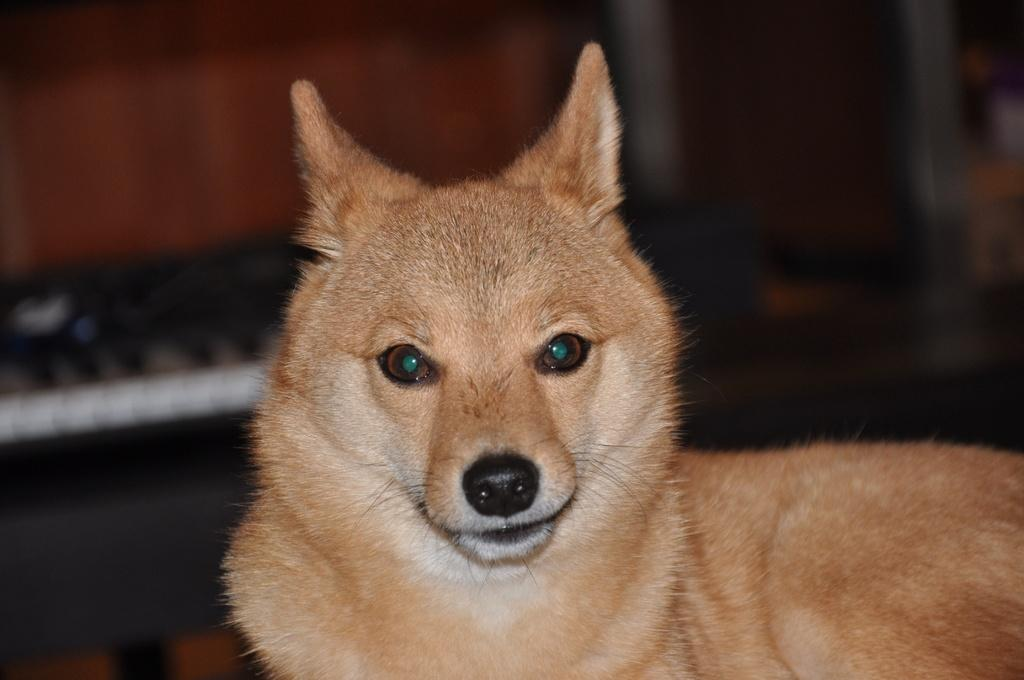What animal can be seen in the image? There is a dog in the image. What is the dog looking at? The dog is looking at a picture. Can you describe the background of the image? The background of the image is blurred. What type of list is the dog sorting through in the image? There is no list present in the image, and the dog is not sorting anything. 